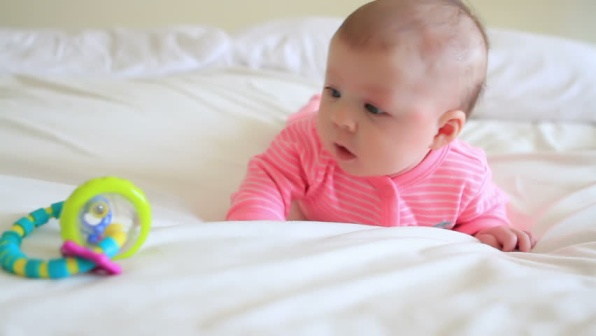Imagine this baby’s thoughts as they look at the toy. The baby might be thinking something like, 'What is this interesting, colorful toy? It moves and makes sounds when I touch it. Maybe if I reach out, I can grab it and learn more about it!' 